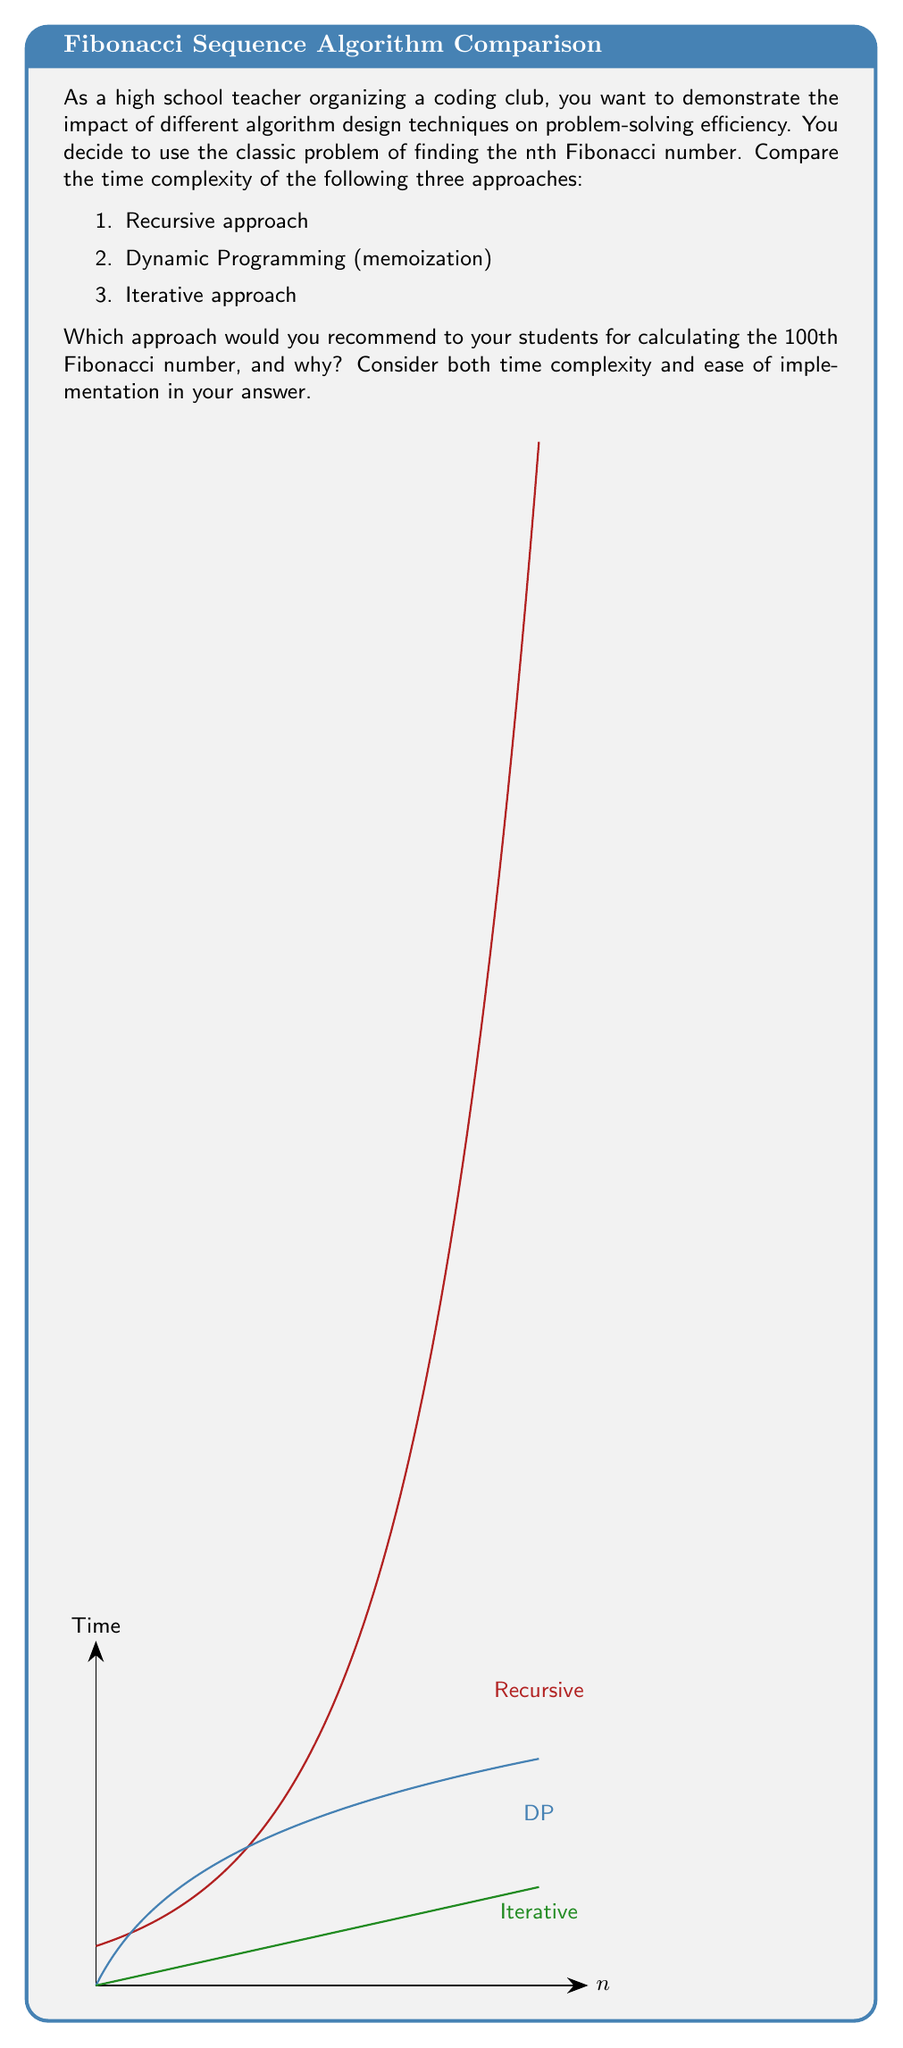Can you solve this math problem? Let's analyze each approach:

1. Recursive approach:
   Time complexity: $O(2^n)$
   This approach directly implements the Fibonacci recurrence relation:
   $$F(n) = F(n-1) + F(n-2)$$
   However, it recalculates many values multiple times, leading to exponential time complexity.

2. Dynamic Programming (memoization):
   Time complexity: $O(n)$
   This approach stores previously calculated Fibonacci numbers in an array or hash table:
   ```
   memo = {}
   def fib(n):
       if n in memo: return memo[n]
       if n <= 1: return n
       memo[n] = fib(n-1) + fib(n-2)
       return memo[n]
   ```
   It calculates each Fibonacci number only once, reducing time complexity to linear.

3. Iterative approach:
   Time complexity: $O(n)$
   This approach uses a loop to calculate Fibonacci numbers:
   ```
   def fib(n):
       if n <= 1: return n
       a, b = 0, 1
       for _ in range(2, n+1):
           a, b = b, a + b
       return b
   ```
   It also has linear time complexity and uses constant extra space.

For calculating the 100th Fibonacci number:
- The recursive approach would be extremely slow, taking approximately $2^{100}$ operations.
- Both dynamic programming and iterative approaches would be efficient, requiring only 100 operations.

Considering both efficiency and ease of implementation, the iterative approach is recommended. It has:
1. Optimal time complexity: $O(n)$
2. Constant space complexity: $O(1)$
3. Simple implementation without recursion or extra data structures

This approach demonstrates how an efficient algorithm can dramatically improve problem-solving speed, an important lesson for students in algorithm design.
Answer: Iterative approach; $O(n)$ time complexity, $O(1)$ space complexity, simple implementation. 